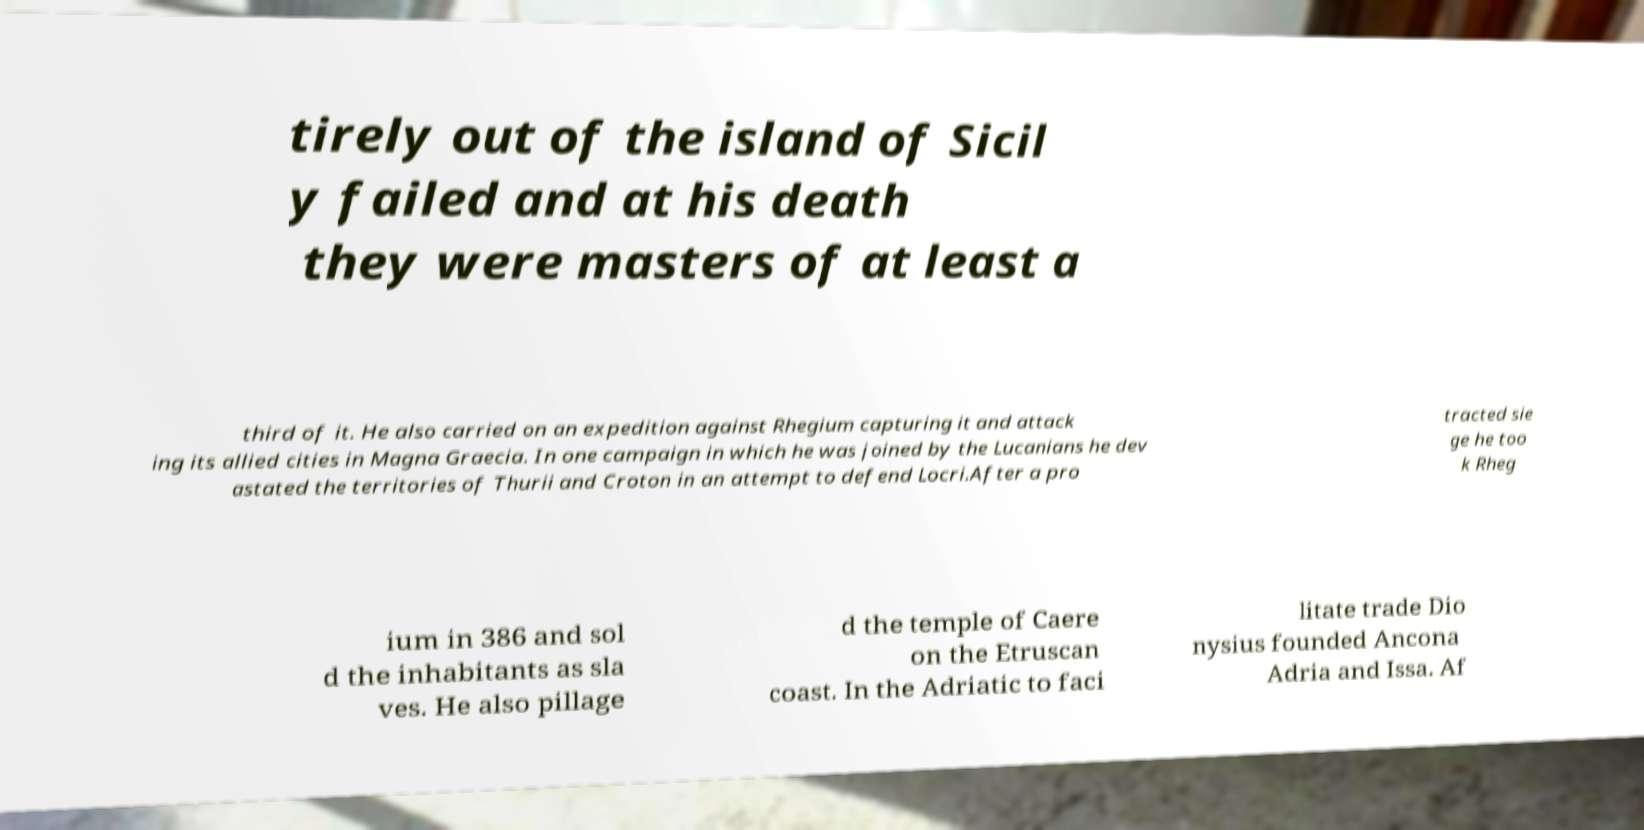Could you assist in decoding the text presented in this image and type it out clearly? tirely out of the island of Sicil y failed and at his death they were masters of at least a third of it. He also carried on an expedition against Rhegium capturing it and attack ing its allied cities in Magna Graecia. In one campaign in which he was joined by the Lucanians he dev astated the territories of Thurii and Croton in an attempt to defend Locri.After a pro tracted sie ge he too k Rheg ium in 386 and sol d the inhabitants as sla ves. He also pillage d the temple of Caere on the Etruscan coast. In the Adriatic to faci litate trade Dio nysius founded Ancona Adria and Issa. Af 